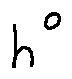<formula> <loc_0><loc_0><loc_500><loc_500>h ^ { 0 }</formula> 